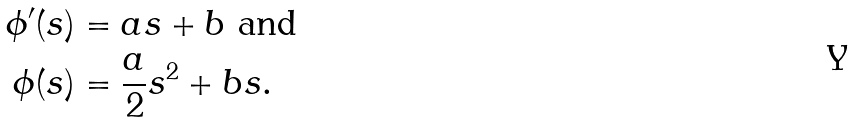<formula> <loc_0><loc_0><loc_500><loc_500>\phi ^ { \prime } ( s ) & = a s + b \text { and} \\ \phi ( s ) & = \frac { a } { 2 } s ^ { 2 } + b s .</formula> 